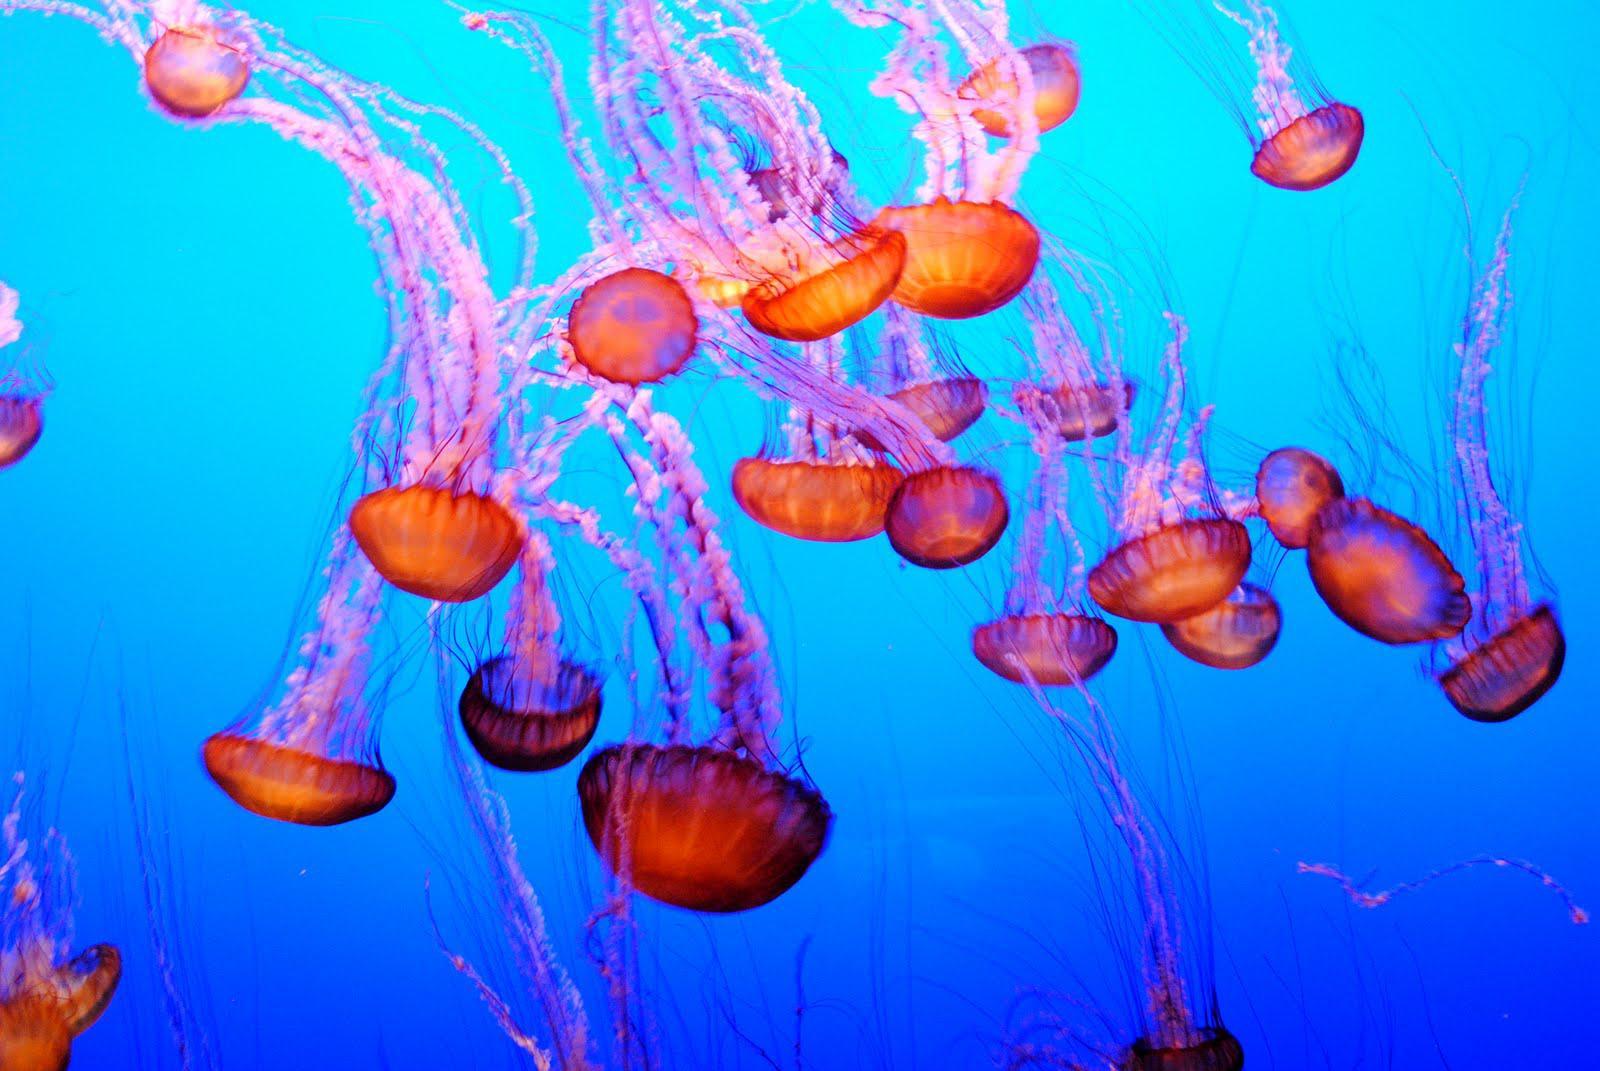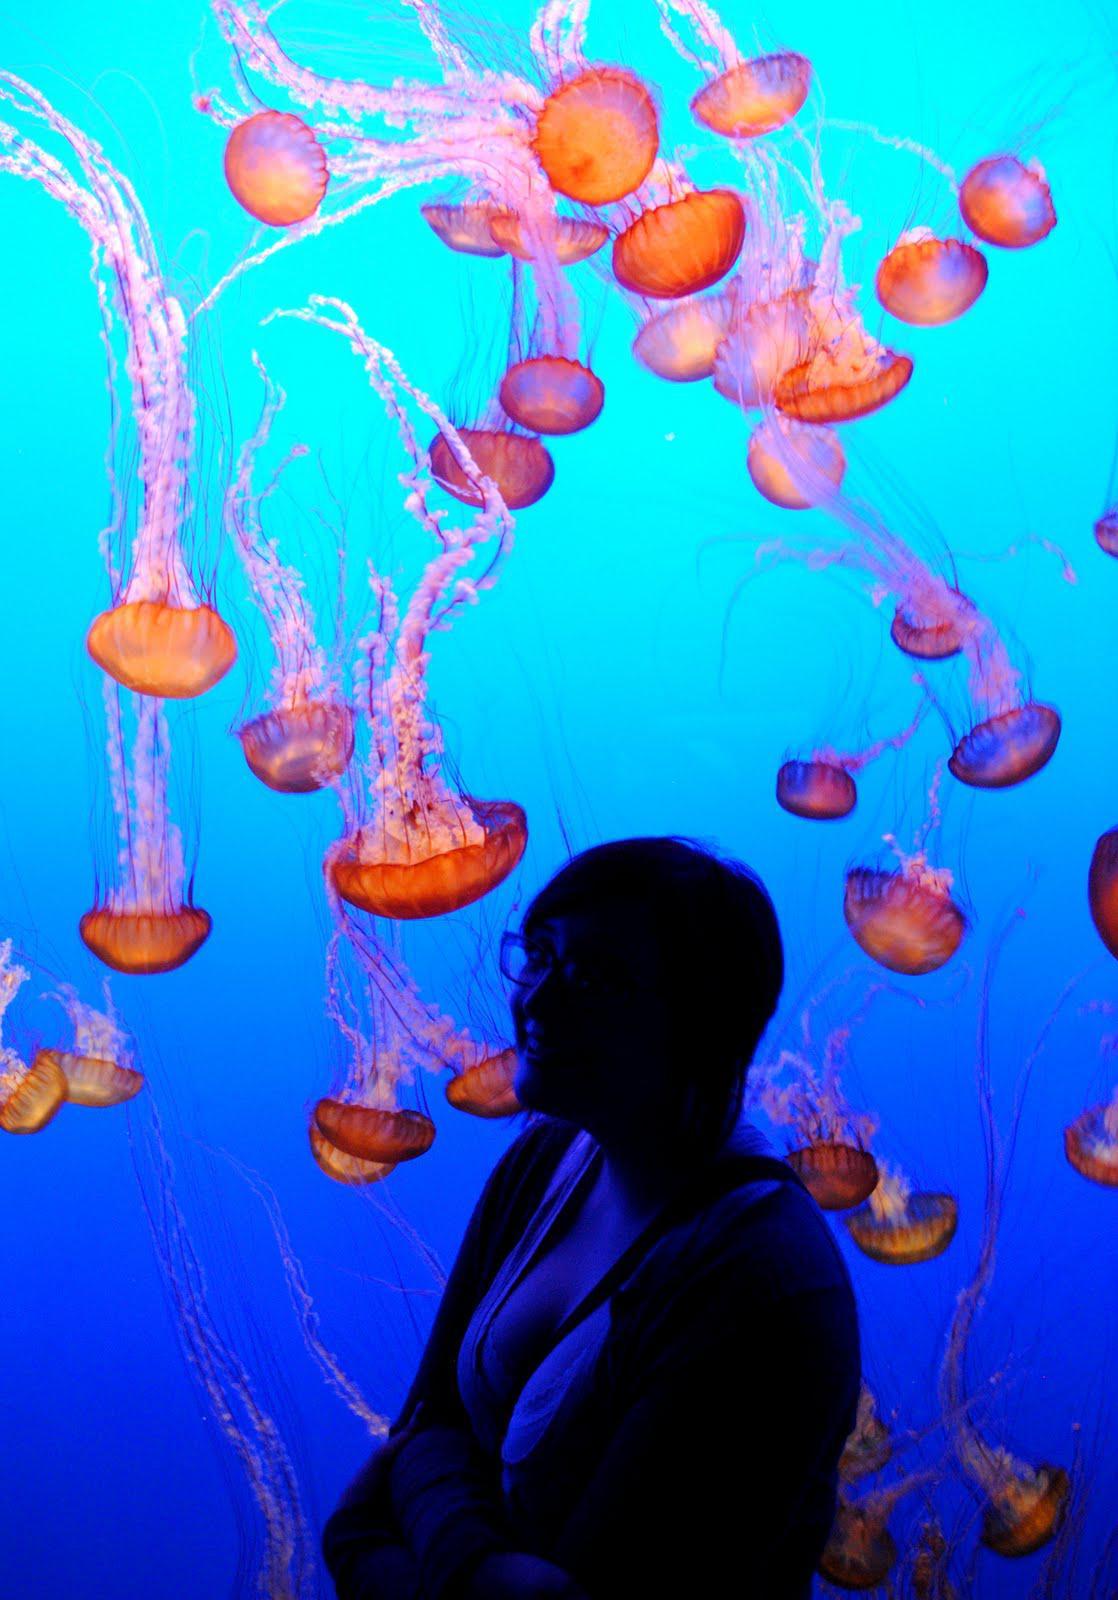The first image is the image on the left, the second image is the image on the right. For the images displayed, is the sentence "There is at least one person in the image on the right" factually correct? Answer yes or no. Yes. 